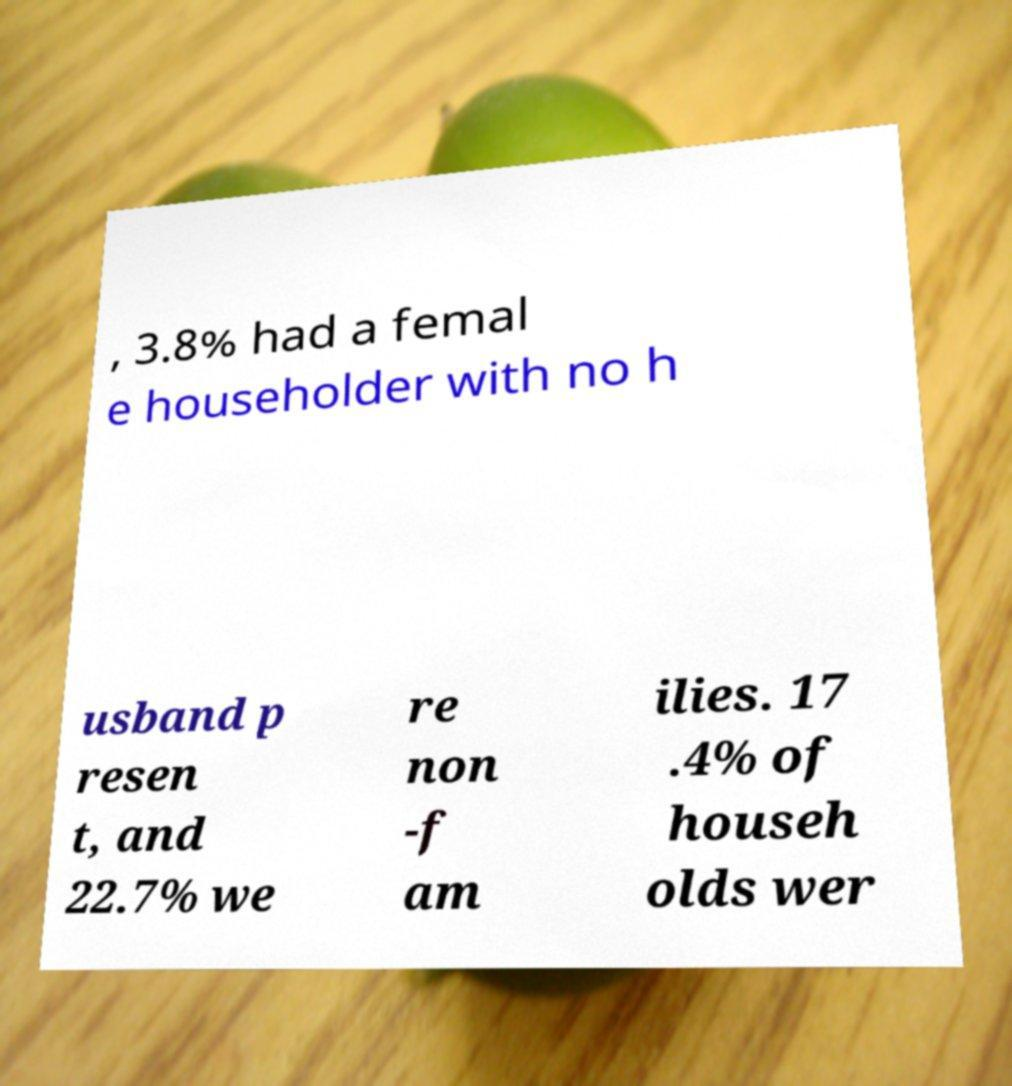Can you accurately transcribe the text from the provided image for me? , 3.8% had a femal e householder with no h usband p resen t, and 22.7% we re non -f am ilies. 17 .4% of househ olds wer 